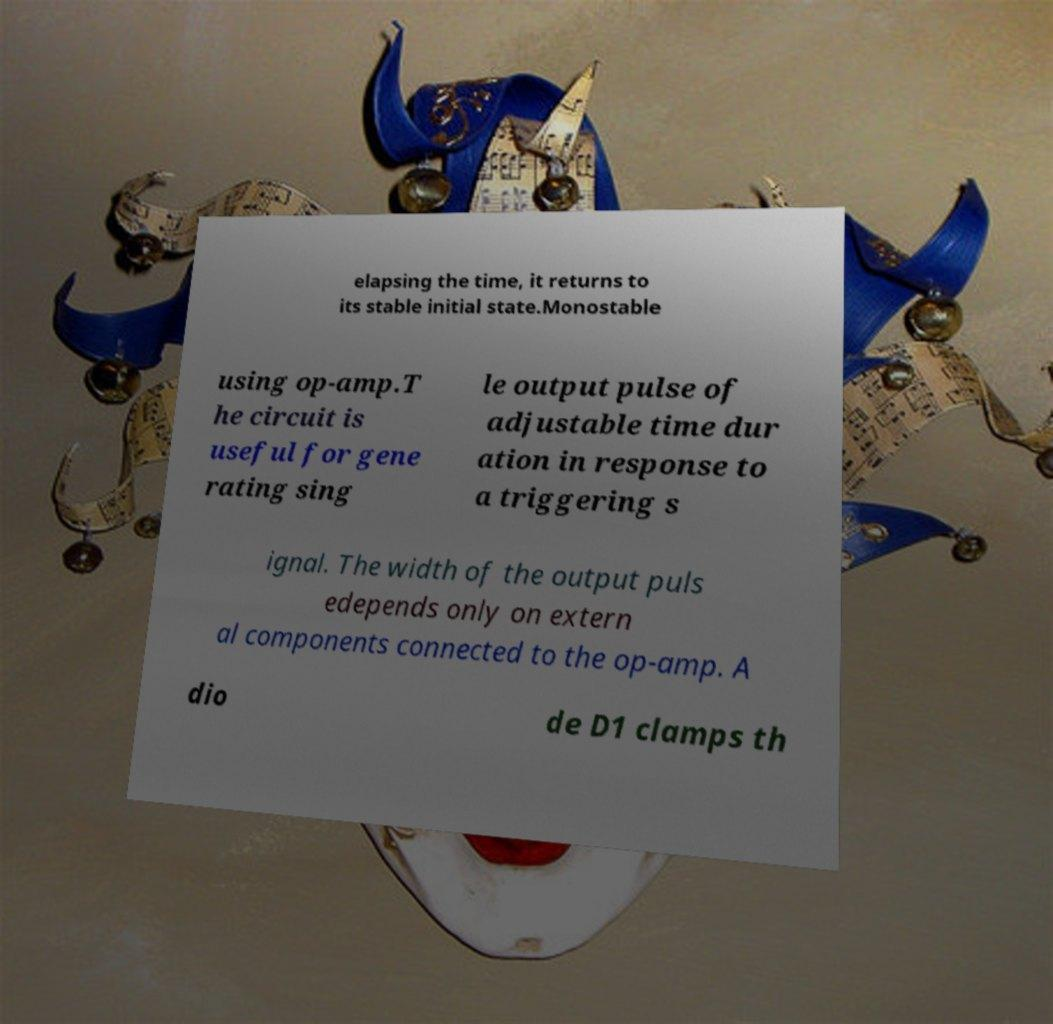I need the written content from this picture converted into text. Can you do that? elapsing the time, it returns to its stable initial state.Monostable using op-amp.T he circuit is useful for gene rating sing le output pulse of adjustable time dur ation in response to a triggering s ignal. The width of the output puls edepends only on extern al components connected to the op-amp. A dio de D1 clamps th 